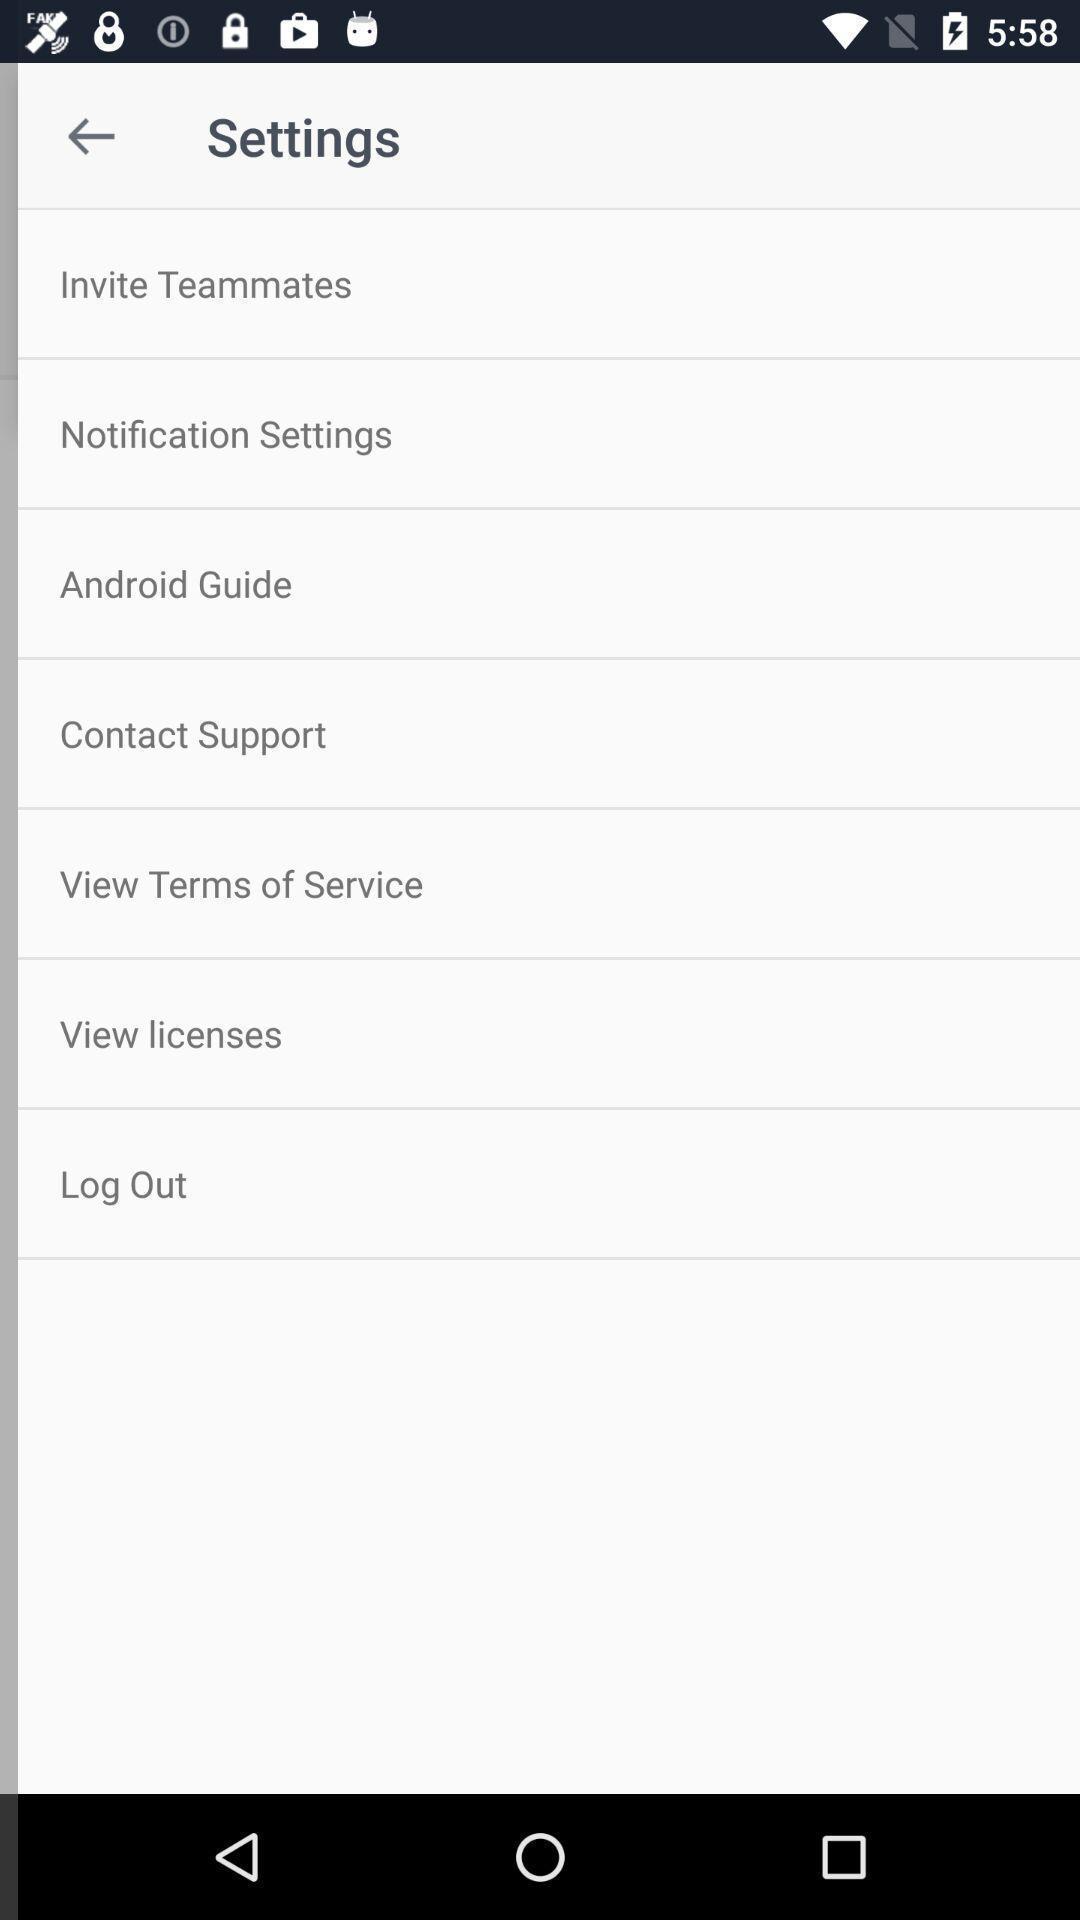What is the overall content of this screenshot? Settings page. 